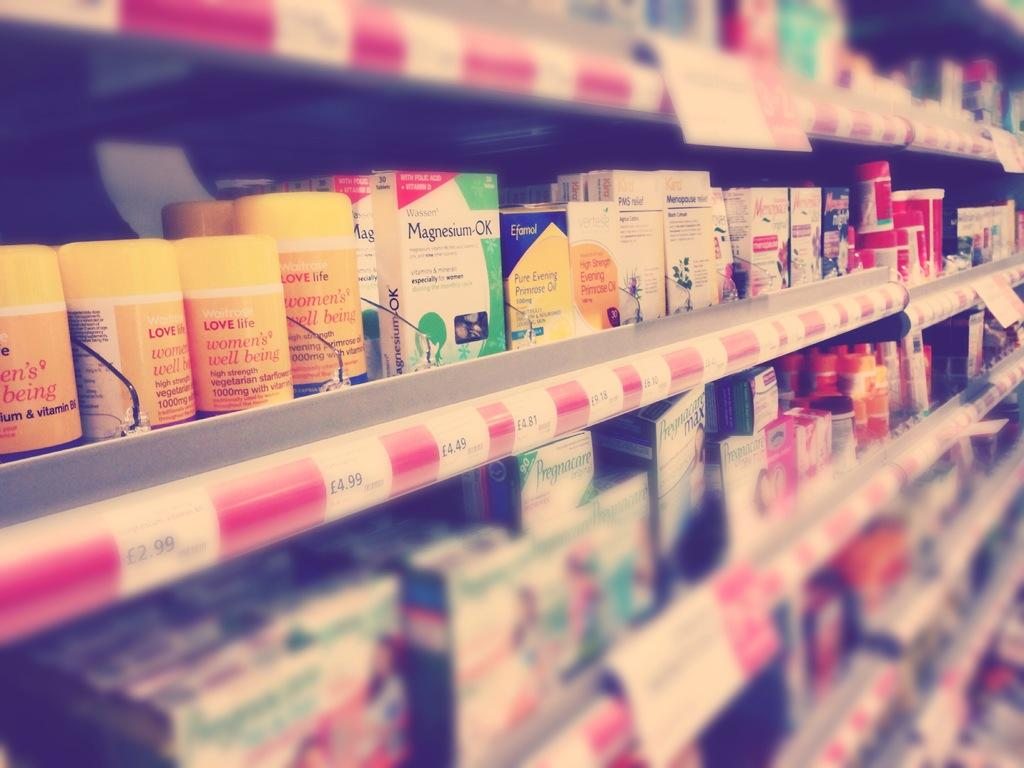<image>
Render a clear and concise summary of the photo. A shelf full of medicine including Magnsium-OK for 4.81 